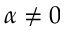Convert formula to latex. <formula><loc_0><loc_0><loc_500><loc_500>\alpha \neq 0</formula> 